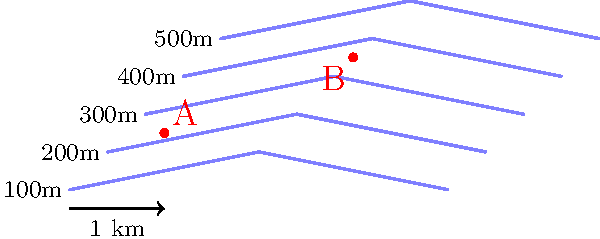Based on the topographic map of a section of the Karakoram mountain range, what is the approximate elevation difference between point A and point B? To find the elevation difference between points A and B, we need to follow these steps:

1. Identify the contour lines near each point:
   - Point A is between the 100m and 200m contour lines
   - Point B is between the 300m and 400m contour lines

2. Estimate the elevation of each point:
   - Point A: It's closer to the 100m line, so approximately 150m
   - Point B: It's about halfway between 300m and 400m, so approximately 350m

3. Calculate the difference:
   $350m - 150m = 200m$

Therefore, the approximate elevation difference between points A and B is 200 meters.
Answer: 200 meters 